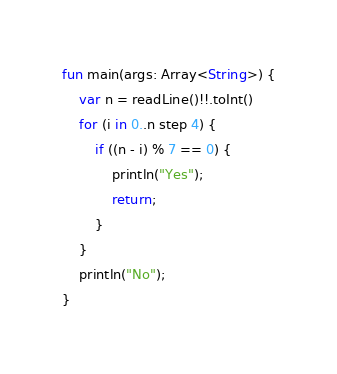Convert code to text. <code><loc_0><loc_0><loc_500><loc_500><_Kotlin_>fun main(args: Array<String>) {
    var n = readLine()!!.toInt()
    for (i in 0..n step 4) {
        if ((n - i) % 7 == 0) {
            println("Yes");
            return;
        }
    }
    println("No");
}</code> 